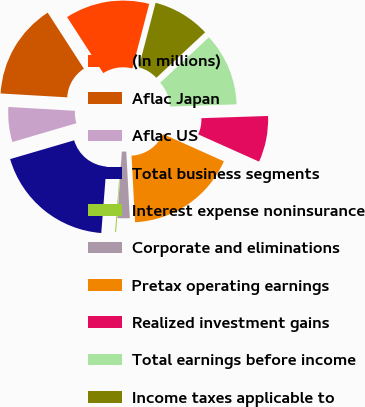Convert chart to OTSL. <chart><loc_0><loc_0><loc_500><loc_500><pie_chart><fcel>(In millions)<fcel>Aflac Japan<fcel>Aflac US<fcel>Total business segments<fcel>Interest expense noninsurance<fcel>Corporate and eliminations<fcel>Pretax operating earnings<fcel>Realized investment gains<fcel>Total earnings before income<fcel>Income taxes applicable to<nl><fcel>13.18%<fcel>14.95%<fcel>5.46%<fcel>19.22%<fcel>0.16%<fcel>1.92%<fcel>17.45%<fcel>7.23%<fcel>11.41%<fcel>9.0%<nl></chart> 